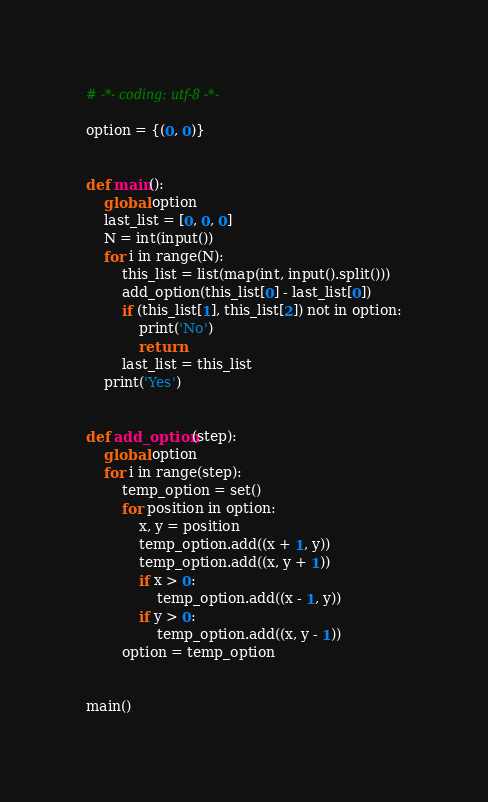Convert code to text. <code><loc_0><loc_0><loc_500><loc_500><_Python_># -*- coding: utf-8 -*-

option = {(0, 0)}


def main():
    global option
    last_list = [0, 0, 0]
    N = int(input())
    for i in range(N):
        this_list = list(map(int, input().split()))
        add_option(this_list[0] - last_list[0])
        if (this_list[1], this_list[2]) not in option:
            print('No')
            return
        last_list = this_list
    print('Yes')


def add_option(step):
    global option
    for i in range(step):
        temp_option = set()
        for position in option:
            x, y = position
            temp_option.add((x + 1, y))
            temp_option.add((x, y + 1))
            if x > 0:
                temp_option.add((x - 1, y))
            if y > 0:
                temp_option.add((x, y - 1))
        option = temp_option


main()
</code> 